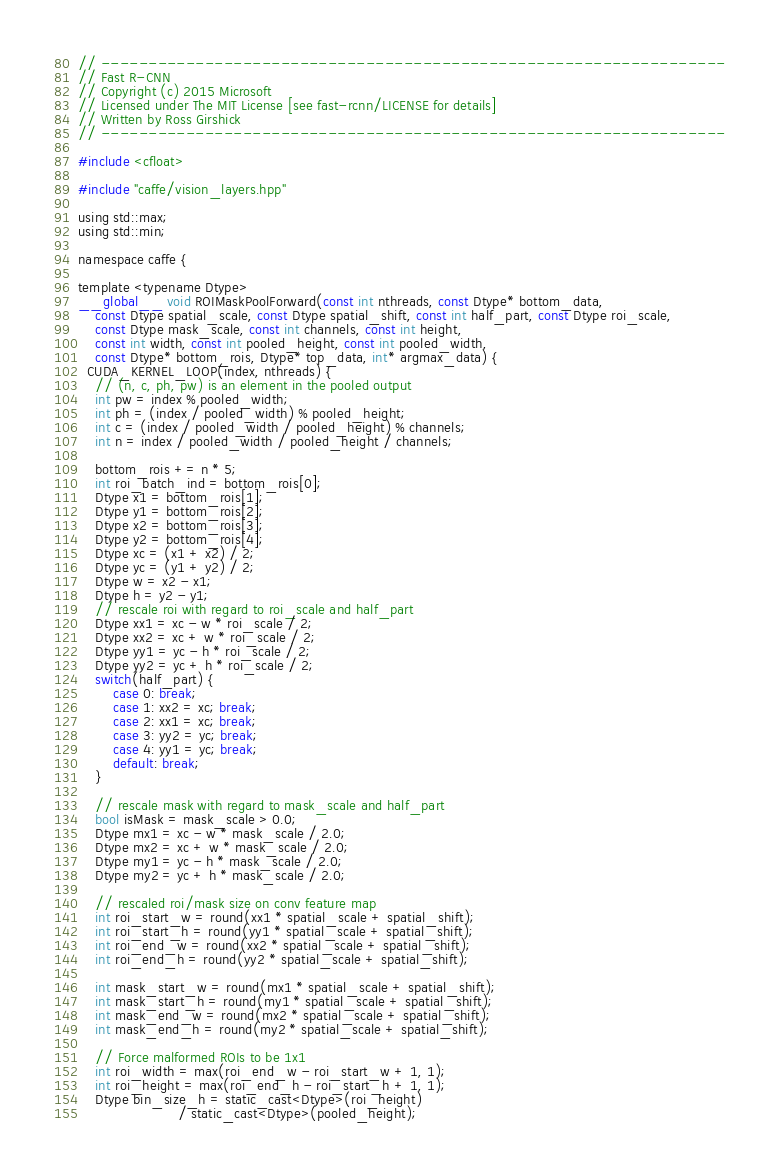Convert code to text. <code><loc_0><loc_0><loc_500><loc_500><_Cuda_>// ------------------------------------------------------------------
// Fast R-CNN
// Copyright (c) 2015 Microsoft
// Licensed under The MIT License [see fast-rcnn/LICENSE for details]
// Written by Ross Girshick
// ------------------------------------------------------------------

#include <cfloat>

#include "caffe/vision_layers.hpp"

using std::max;
using std::min;

namespace caffe {

template <typename Dtype>
__global__ void ROIMaskPoolForward(const int nthreads, const Dtype* bottom_data,
    const Dtype spatial_scale, const Dtype spatial_shift, const int half_part, const Dtype roi_scale,
    const Dtype mask_scale, const int channels, const int height,
    const int width, const int pooled_height, const int pooled_width,
    const Dtype* bottom_rois, Dtype* top_data, int* argmax_data) {
  CUDA_KERNEL_LOOP(index, nthreads) {
    // (n, c, ph, pw) is an element in the pooled output
    int pw = index % pooled_width;
    int ph = (index / pooled_width) % pooled_height;
    int c = (index / pooled_width / pooled_height) % channels;
    int n = index / pooled_width / pooled_height / channels;

    bottom_rois += n * 5;
    int roi_batch_ind = bottom_rois[0];
    Dtype x1 = bottom_rois[1];
    Dtype y1 = bottom_rois[2];
    Dtype x2 = bottom_rois[3];
    Dtype y2 = bottom_rois[4];
    Dtype xc = (x1 + x2) / 2;
    Dtype yc = (y1 + y2) / 2;
    Dtype w = x2 - x1;
    Dtype h = y2 - y1;
    // rescale roi with regard to roi_scale and half_part
    Dtype xx1 = xc - w * roi_scale / 2;
    Dtype xx2 = xc + w * roi_scale / 2;
    Dtype yy1 = yc - h * roi_scale / 2;
    Dtype yy2 = yc + h * roi_scale / 2;
    switch(half_part) {
        case 0: break;
        case 1: xx2 = xc; break;
        case 2: xx1 = xc; break;
        case 3: yy2 = yc; break;
        case 4: yy1 = yc; break;
        default: break;
    }

    // rescale mask with regard to mask_scale and half_part
    bool isMask = mask_scale > 0.0;
    Dtype mx1 = xc - w * mask_scale / 2.0;
    Dtype mx2 = xc + w * mask_scale / 2.0;
    Dtype my1 = yc - h * mask_scale / 2.0;
    Dtype my2 = yc + h * mask_scale / 2.0;

    // rescaled roi/mask size on conv feature map
    int roi_start_w = round(xx1 * spatial_scale + spatial_shift);
    int roi_start_h = round(yy1 * spatial_scale + spatial_shift);
    int roi_end_w = round(xx2 * spatial_scale + spatial_shift);
    int roi_end_h = round(yy2 * spatial_scale + spatial_shift);

    int mask_start_w = round(mx1 * spatial_scale + spatial_shift);
    int mask_start_h = round(my1 * spatial_scale + spatial_shift);
    int mask_end_w = round(mx2 * spatial_scale + spatial_shift);
    int mask_end_h = round(my2 * spatial_scale + spatial_shift);

    // Force malformed ROIs to be 1x1
    int roi_width = max(roi_end_w - roi_start_w + 1, 1);
    int roi_height = max(roi_end_h - roi_start_h + 1, 1);
    Dtype bin_size_h = static_cast<Dtype>(roi_height)
                       / static_cast<Dtype>(pooled_height);</code> 